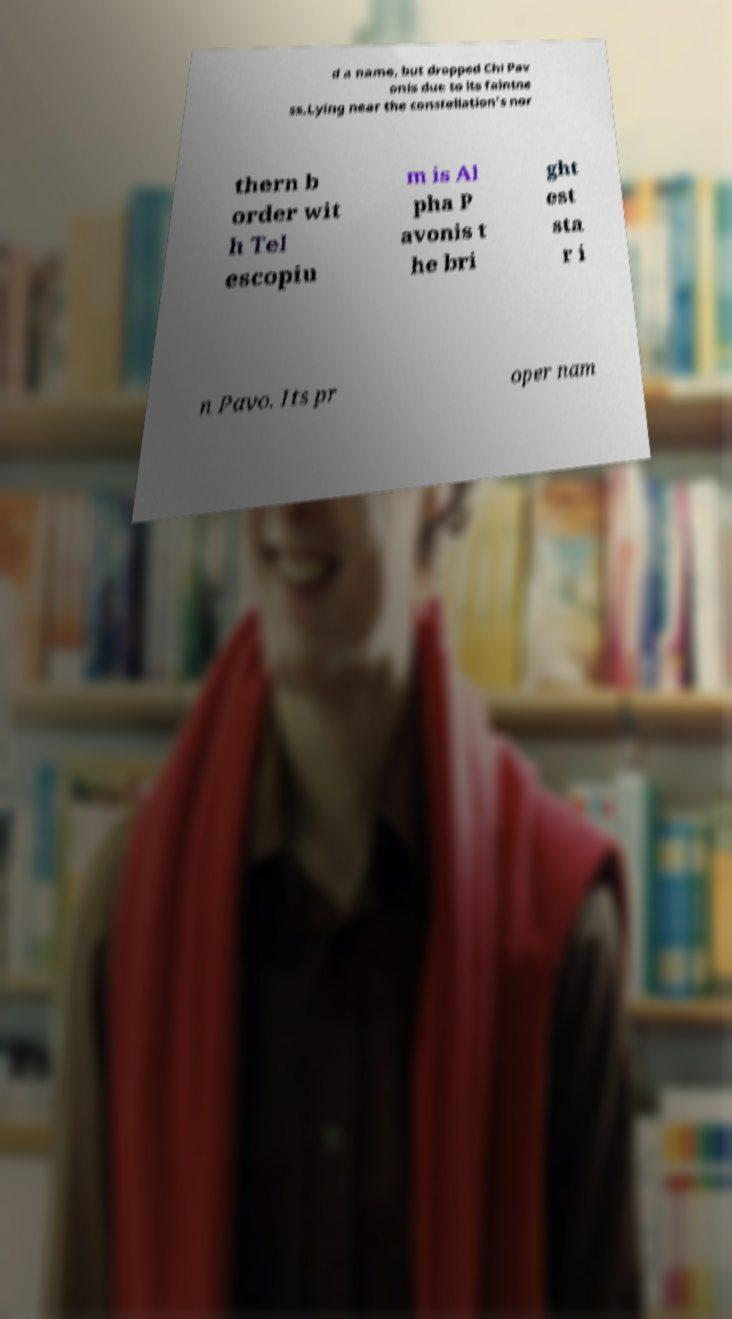For documentation purposes, I need the text within this image transcribed. Could you provide that? d a name, but dropped Chi Pav onis due to its faintne ss.Lying near the constellation's nor thern b order wit h Tel escopiu m is Al pha P avonis t he bri ght est sta r i n Pavo. Its pr oper nam 